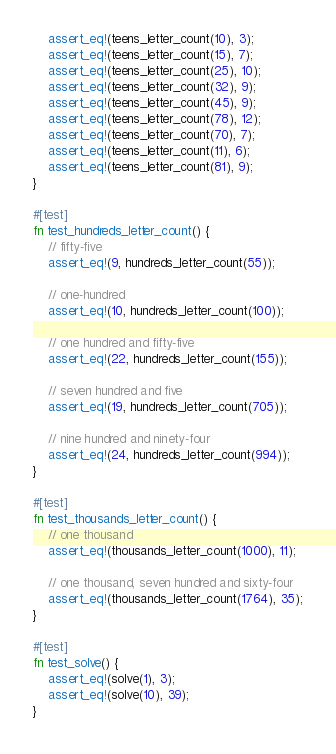Convert code to text. <code><loc_0><loc_0><loc_500><loc_500><_Rust_>    assert_eq!(teens_letter_count(10), 3);
    assert_eq!(teens_letter_count(15), 7);
    assert_eq!(teens_letter_count(25), 10);
    assert_eq!(teens_letter_count(32), 9);
    assert_eq!(teens_letter_count(45), 9);
    assert_eq!(teens_letter_count(78), 12);
    assert_eq!(teens_letter_count(70), 7);
    assert_eq!(teens_letter_count(11), 6);
    assert_eq!(teens_letter_count(81), 9);
}

#[test]
fn test_hundreds_letter_count() {
    // fifty-five
    assert_eq!(9, hundreds_letter_count(55));

    // one-hundred
    assert_eq!(10, hundreds_letter_count(100));

    // one hundred and fifty-five
    assert_eq!(22, hundreds_letter_count(155));

    // seven hundred and five
    assert_eq!(19, hundreds_letter_count(705));

    // nine hundred and ninety-four
    assert_eq!(24, hundreds_letter_count(994));
}

#[test]
fn test_thousands_letter_count() {
    // one thousand
    assert_eq!(thousands_letter_count(1000), 11);

    // one thousand, seven hundred and sixty-four
    assert_eq!(thousands_letter_count(1764), 35);
}

#[test]
fn test_solve() {
    assert_eq!(solve(1), 3);
    assert_eq!(solve(10), 39);
}
</code> 